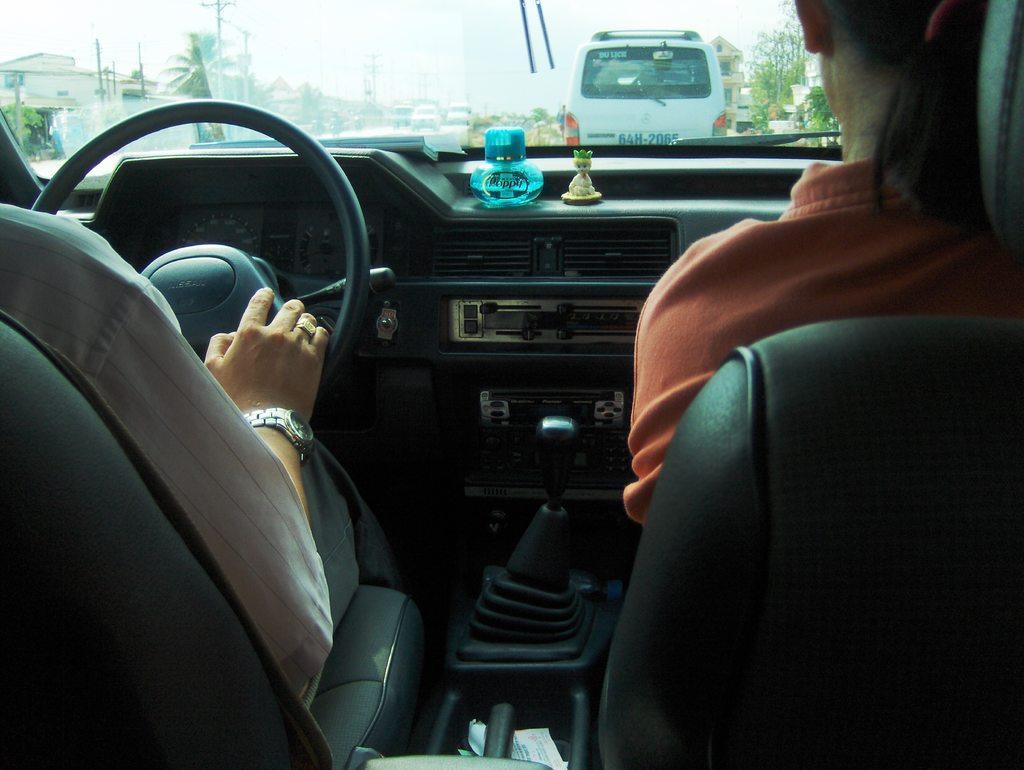Describe this image in one or two sentences. There are two persons inside a vehicle. There is a bottle and a toy. From the glass we can see vehicles, trees, poles, buildings, and sky. 